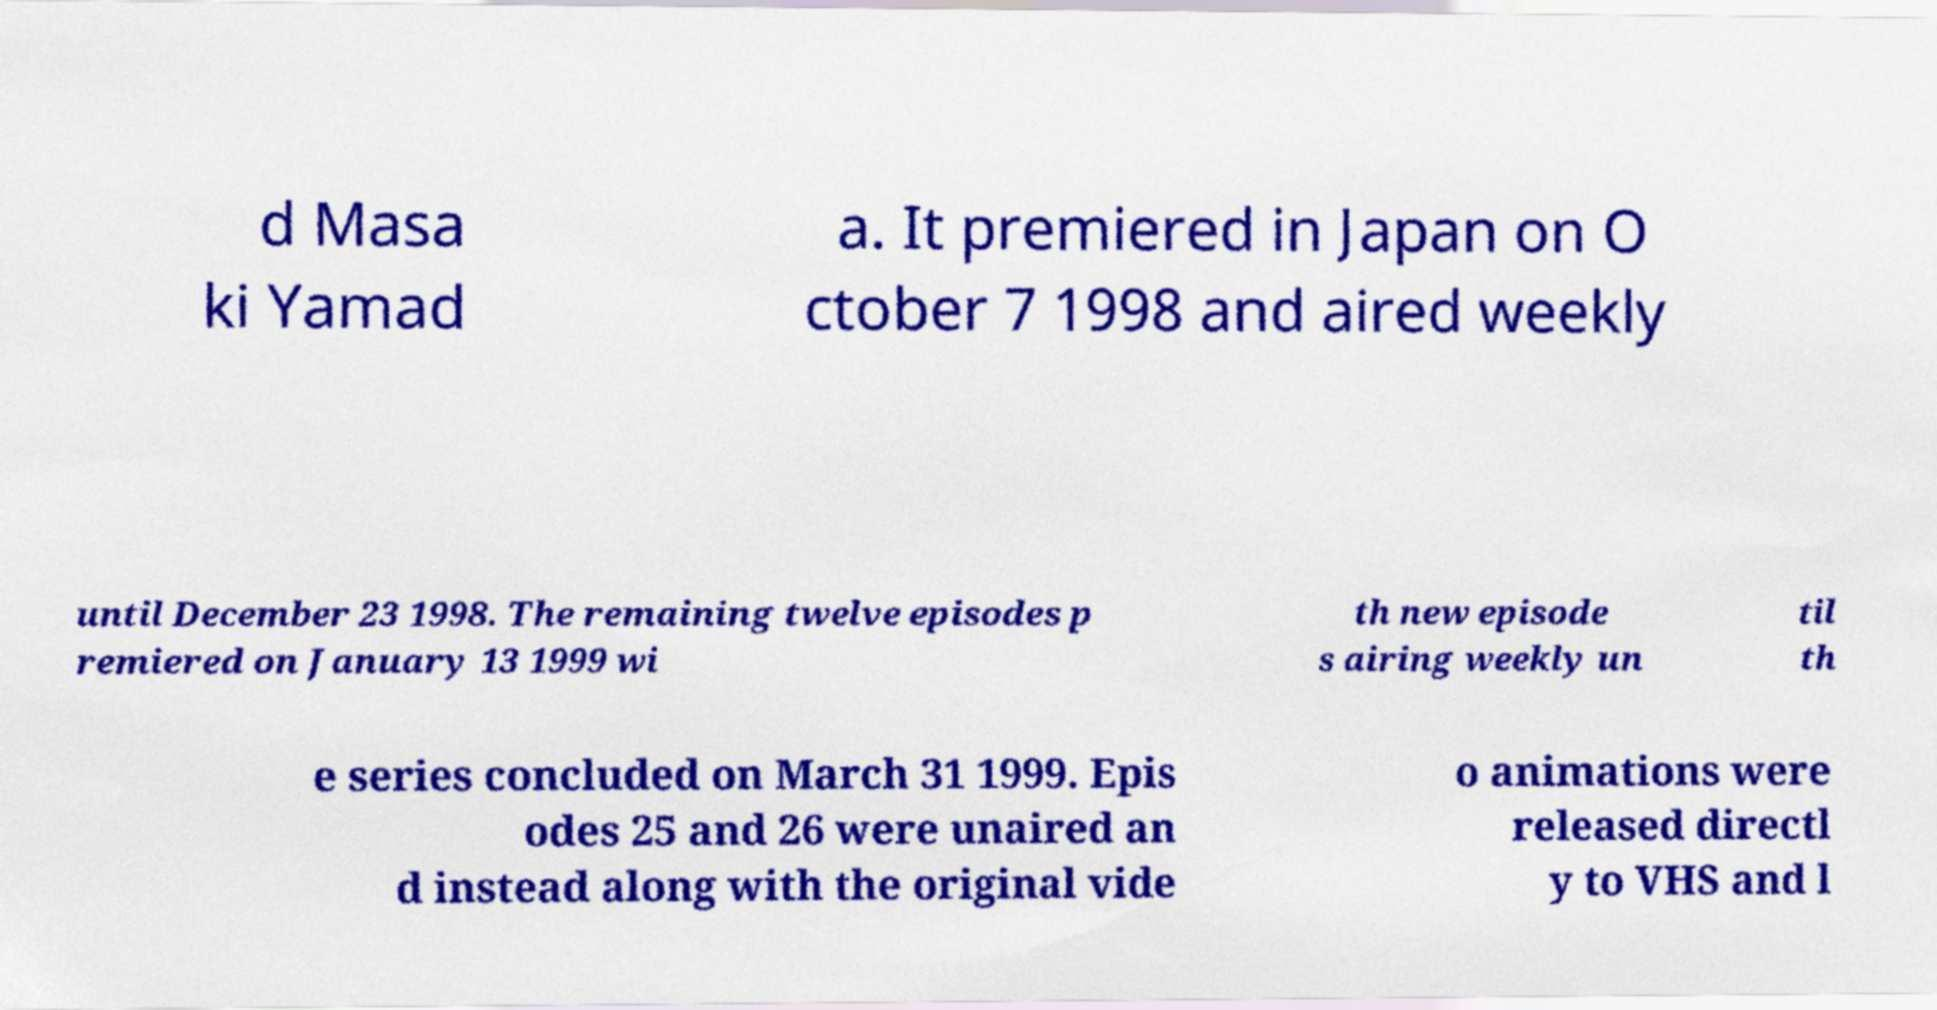Can you accurately transcribe the text from the provided image for me? d Masa ki Yamad a. It premiered in Japan on O ctober 7 1998 and aired weekly until December 23 1998. The remaining twelve episodes p remiered on January 13 1999 wi th new episode s airing weekly un til th e series concluded on March 31 1999. Epis odes 25 and 26 were unaired an d instead along with the original vide o animations were released directl y to VHS and l 